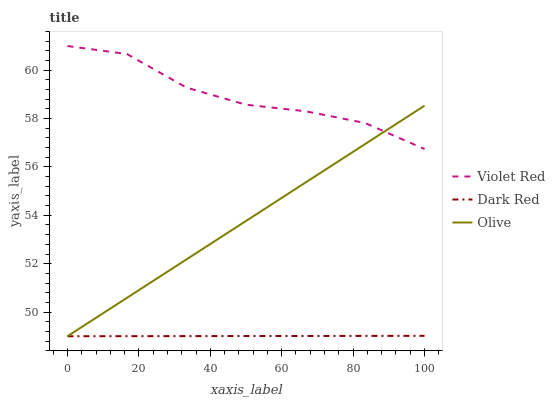Does Dark Red have the minimum area under the curve?
Answer yes or no. Yes. Does Violet Red have the maximum area under the curve?
Answer yes or no. Yes. Does Violet Red have the minimum area under the curve?
Answer yes or no. No. Does Dark Red have the maximum area under the curve?
Answer yes or no. No. Is Dark Red the smoothest?
Answer yes or no. Yes. Is Violet Red the roughest?
Answer yes or no. Yes. Is Violet Red the smoothest?
Answer yes or no. No. Is Dark Red the roughest?
Answer yes or no. No. Does Violet Red have the lowest value?
Answer yes or no. No. Does Violet Red have the highest value?
Answer yes or no. Yes. Does Dark Red have the highest value?
Answer yes or no. No. Is Dark Red less than Violet Red?
Answer yes or no. Yes. Is Violet Red greater than Dark Red?
Answer yes or no. Yes. Does Olive intersect Dark Red?
Answer yes or no. Yes. Is Olive less than Dark Red?
Answer yes or no. No. Is Olive greater than Dark Red?
Answer yes or no. No. Does Dark Red intersect Violet Red?
Answer yes or no. No. 